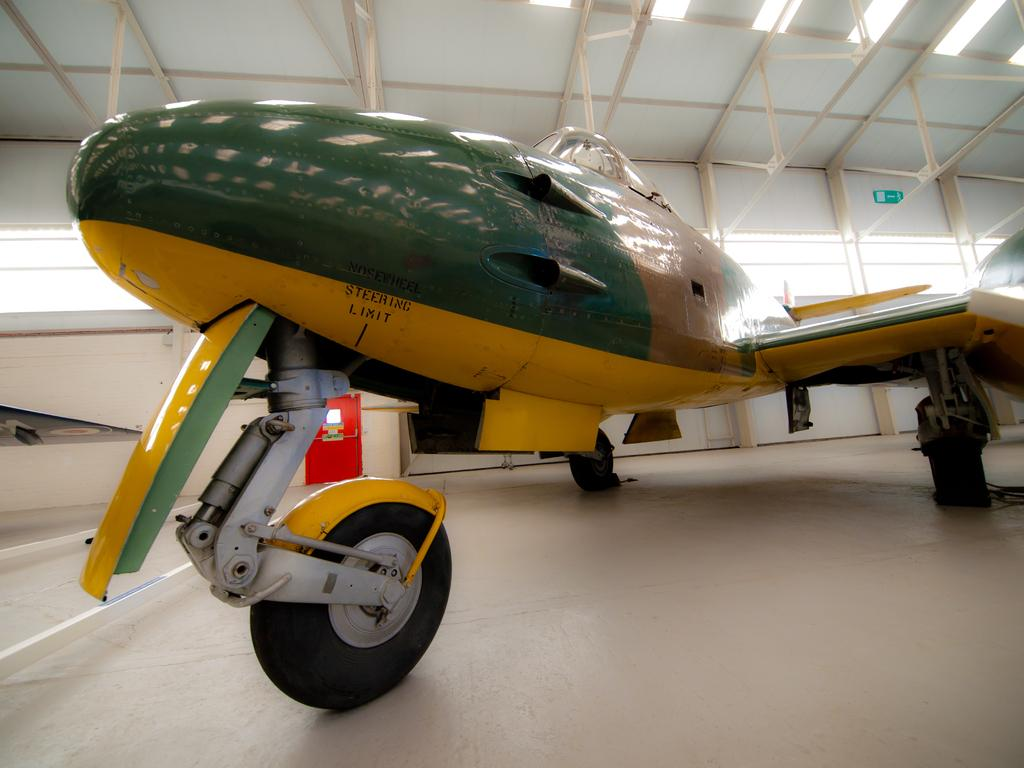What type of object is present on the ground in the image? There is a vehicle in the image. Can you describe the position of the vehicle in the image? The vehicle is on the ground. What is written or displayed on the vehicle? There is text on the vehicle. What can be seen behind the vehicle in the image? There is a wall behind the vehicle. What is visible at the top of the image? The ceiling is visible at the top of the image. How does the wind affect the vehicle in the image? There is no wind present in the image, so its effect on the vehicle cannot be determined. 